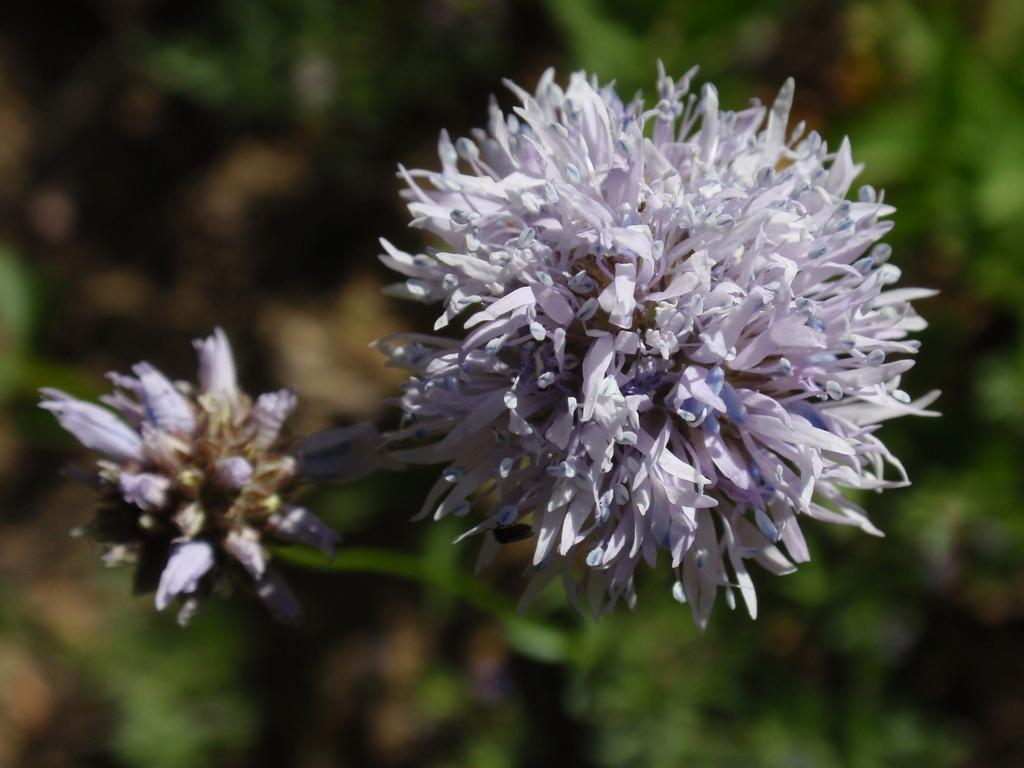What is the main subject of the image? There is a flower in the image. Can you describe the colors of the flower? The flower has white and blue colors. What can be seen in the background of the image? There are plants in the background of the image. How is the background of the image depicted? The background is blurred. What type of impulse can be seen affecting the clouds in the image? There are no clouds present in the image, so it is not possible to determine if any impulse is affecting them. 